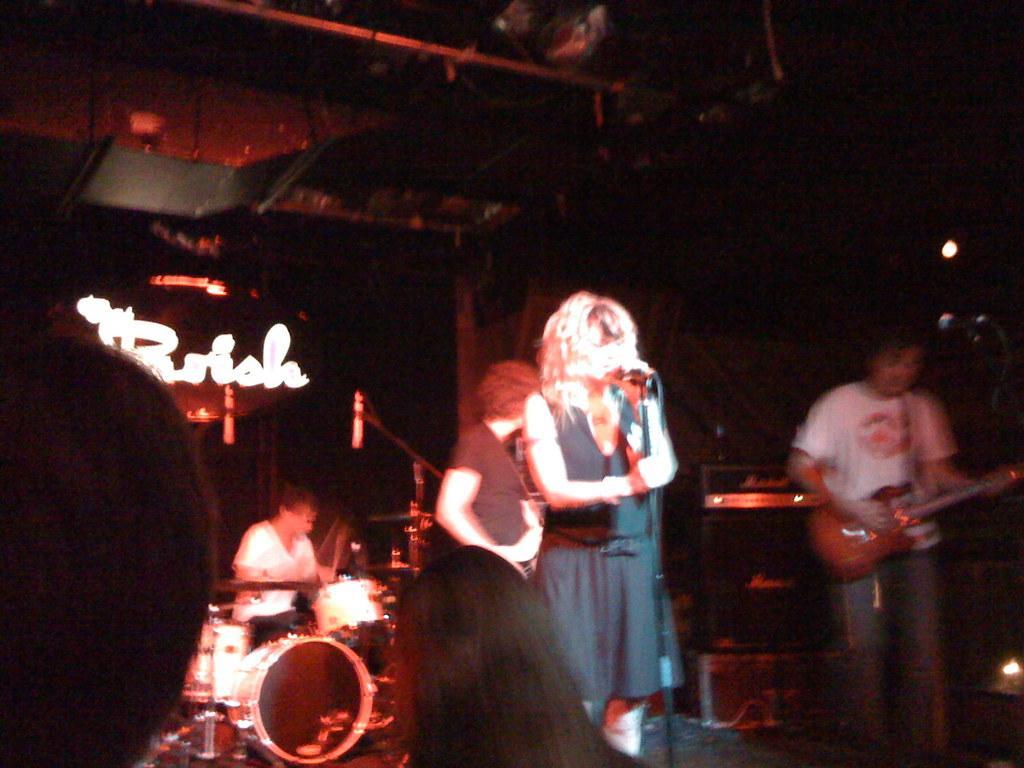Describe this image in one or two sentences. In this picture we can see some people, musical instruments, mics, lights, some objects and a man holding a guitar with his hands and in the background it is dark. 